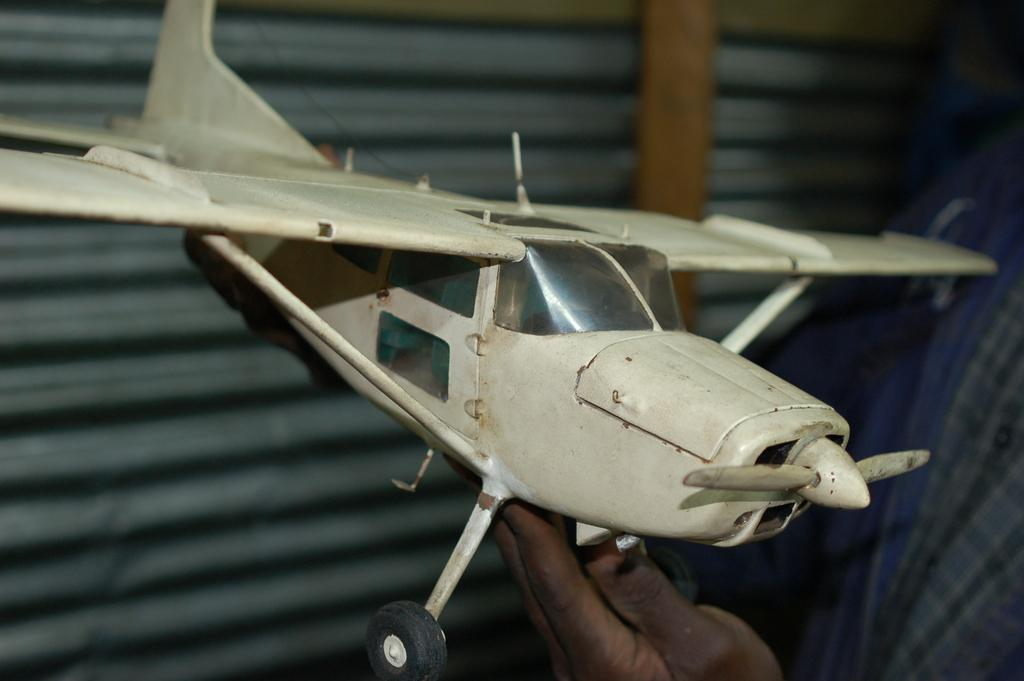What object is the main focus of the image? There is a white-colored aeroplane toy in the image. Who or what is holding the aeroplane toy? A human hand is holding the aeroplane toy. What can be seen on the left side of the image? There is an iron sheet wall on the left side of the image. How many quarters are visible on the iron sheet wall in the image? There are no quarters visible on the iron sheet wall in the image. Are there any brothers playing with the aeroplane toy in the image? There is no indication of any brothers or other people playing with the aeroplane toy in the image. 